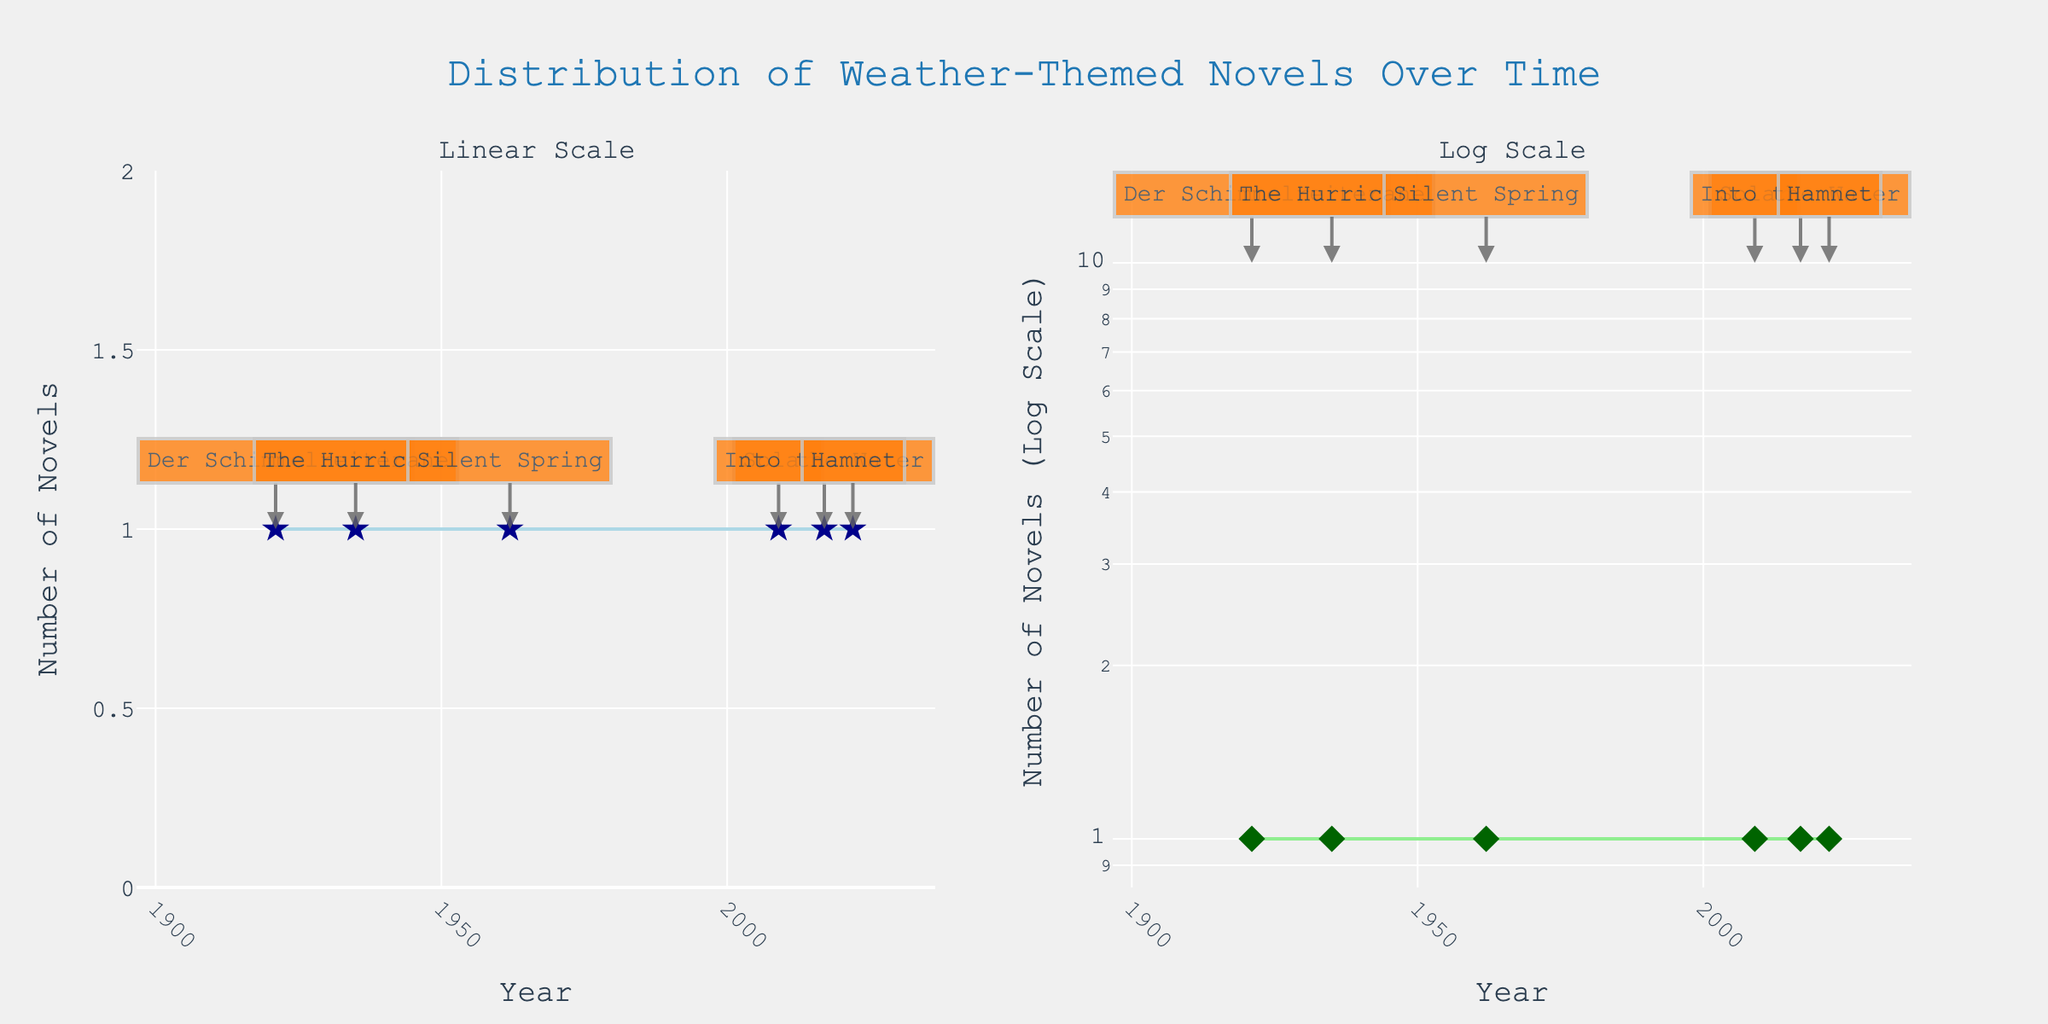What is the title of the figure? The title of the figure is displayed at the top of the plot. It reads "Distribution of Weather-Themed Novels Over Time".
Answer: Distribution of Weather-Themed Novels Over Time How many weather-themed novels were published in 1962? From looking at the data point in the figure for the year 1962, there is one novel indicated by the marker.
Answer: 1 Which year had the earliest weather-themed novel publication based on the figure? Inspecting the earliest x-axis value with a data point reveals the year 1921, when "Der Schimmelreiter" was published.
Answer: 1921 In which years were multiple novels published? On the figure, each year has only one marker, indicating that in all presented years, only one novel was published per year.
Answer: None On the log scale plot, how does the spacing of points compare to the linear scale plot? On a log scale, the spacing between the points can seem more evenly distributed compared to the linear scale, especially if the values vary by orders of magnitude. By observing, the spacing indeed appears more uniform for the y-axis.
Answer: More evenly distributed What are the names of the novels shown for the year 2009, based on their annotations? By locating the annotation for the year 2009 on either subplot, the novel "Solar" is displayed next to the data point.
Answer: Solar How many years are displayed on the x-axis for both subplots combined? Counting each year label on the x-axis of both subplots, there are the same six years shown across both.
Answer: 6 Which year had the most recent weather-themed novel publication? Observing the rightmost data point on the x-axis, it indicates the year 2022, showing "Hamnet" as the most recent novel published.
Answer: 2022 What is the color of the markers used in the log scale subplot? The markers in the log scale subplot are colored dark green as indicated by their presence and description in the plot.
Answer: Dark green How does the general trend of the number of novels published change over the last century in the linear plot? By observing the linear scale plot, the number of weather-themed novels generally appears to be sparse, with publication years spread out over the century without a clear increasing or decreasing trend line.
Answer: Sparse and no clear trend 